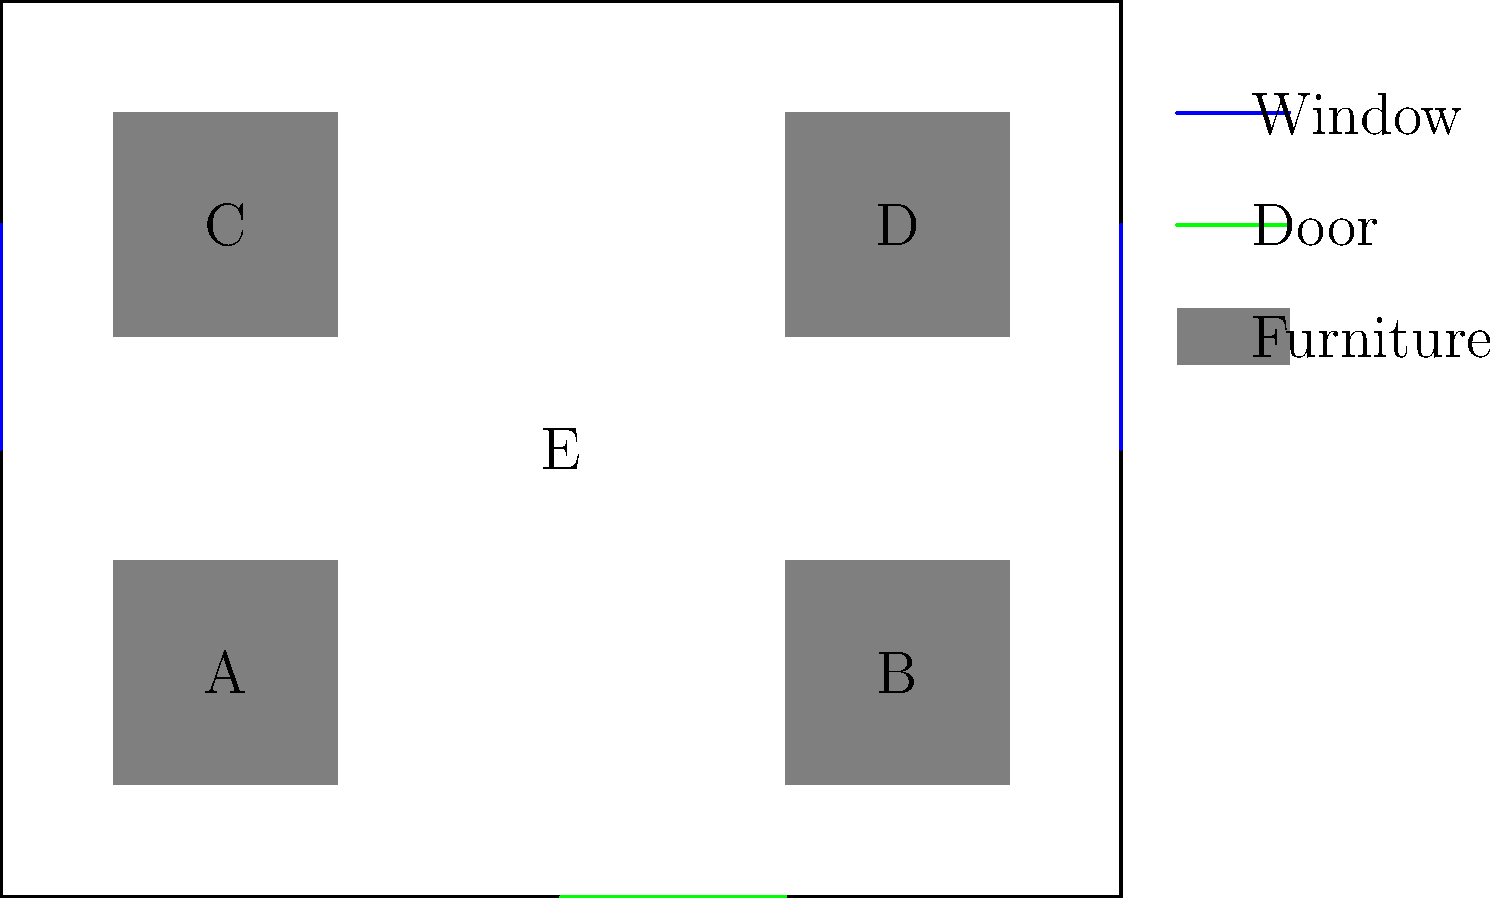In the therapy room floor plan shown above, which area would be most suitable as a "safe space" for a trauma survivor who is triggered by sudden noises and prefers to have a clear view of exits? To determine the most suitable "safe space" for a trauma survivor triggered by sudden noises and preferring a clear view of exits, let's analyze each area:

1. Area A: Near a window, but far from the door. It might feel trapped.
2. Area B: Near a window and close to the door, but might be too exposed.
3. Area C: Near a window, but far from the door and might feel trapped.
4. Area D: Near a window and has a view of the door, but might be too exposed.
5. Area E: Central location with no immediate access to windows or doors.

The ideal safe space should:
a) Be away from potential sudden noise sources (like doors)
b) Provide a clear view of exits
c) Offer some sense of security without feeling trapped

Considering these factors:
- Area C provides a good balance of safety and awareness.
- It's near a window, offering a potential escape route and natural light.
- It's far enough from the door to minimize sudden noise disturbances.
- It allows a clear view of the main door and most of the room.
- The furniture provides a sense of protection without feeling trapped.

Therefore, Area C is the most suitable "safe space" for this trauma survivor.
Answer: Area C 